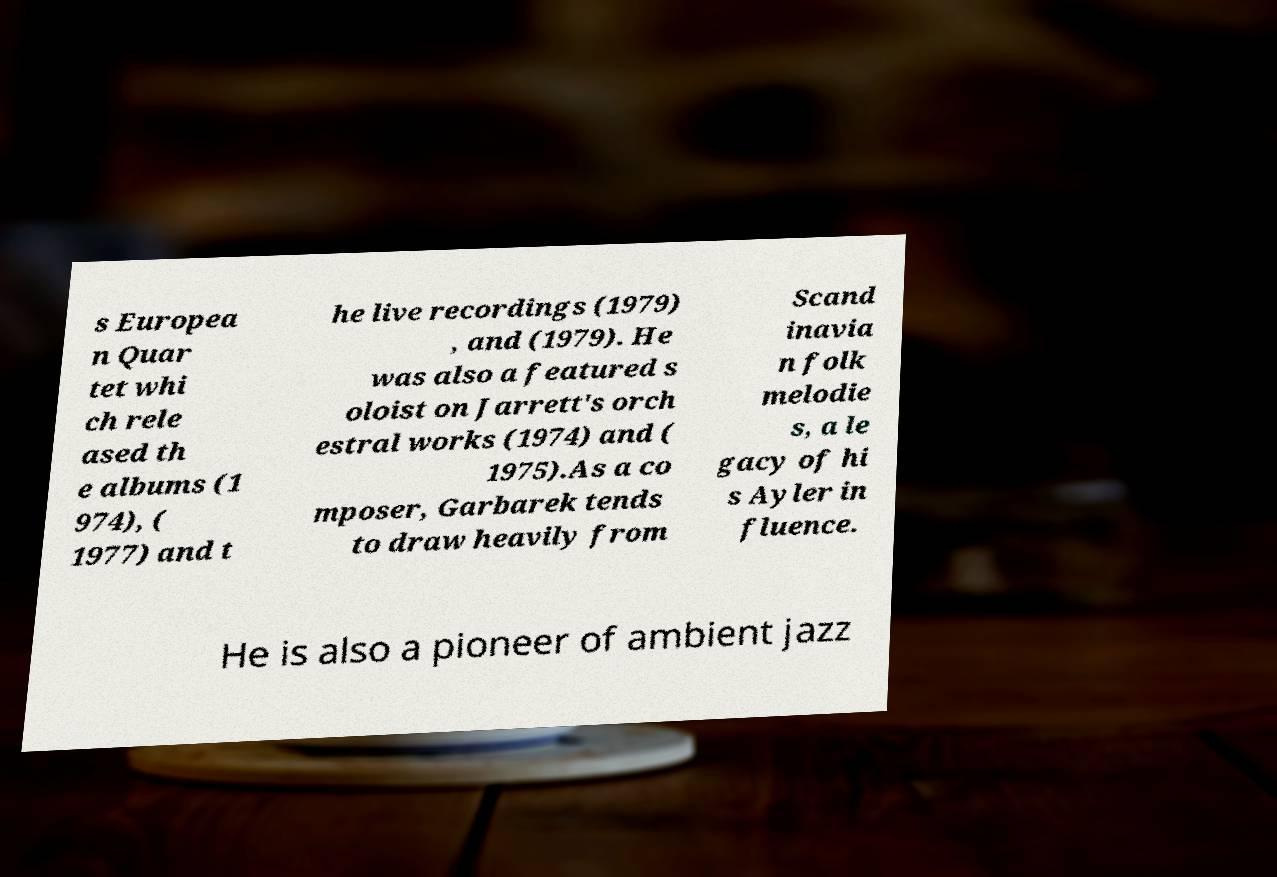I need the written content from this picture converted into text. Can you do that? s Europea n Quar tet whi ch rele ased th e albums (1 974), ( 1977) and t he live recordings (1979) , and (1979). He was also a featured s oloist on Jarrett's orch estral works (1974) and ( 1975).As a co mposer, Garbarek tends to draw heavily from Scand inavia n folk melodie s, a le gacy of hi s Ayler in fluence. He is also a pioneer of ambient jazz 